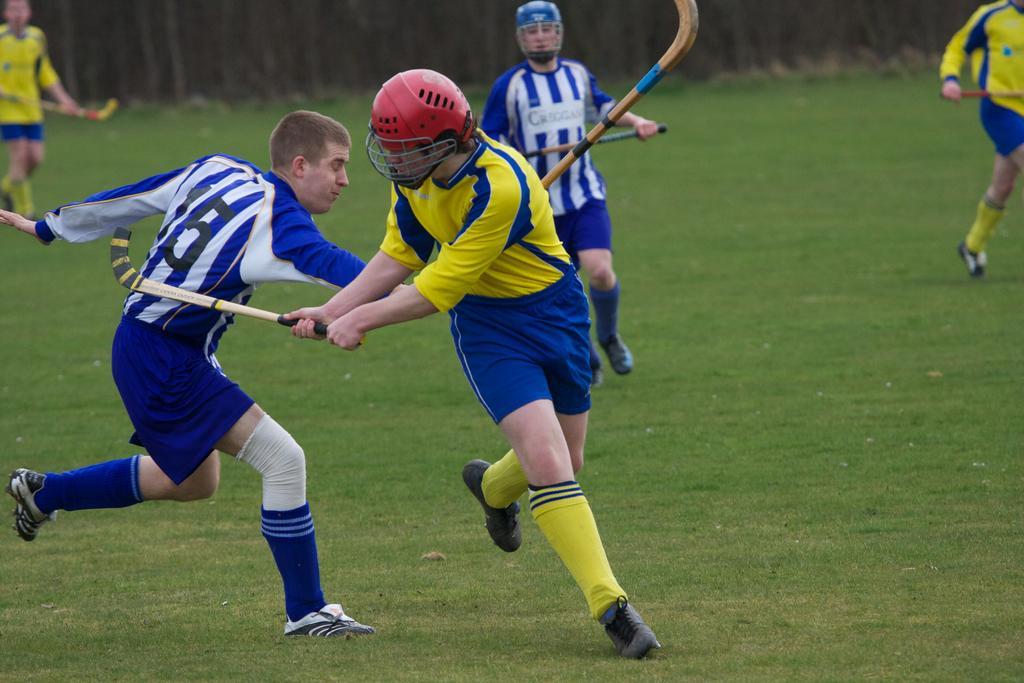Can you describe this image briefly? In this picture we can see a group of people holding bats with their hands and running on the ground where two persons wore helmets. 